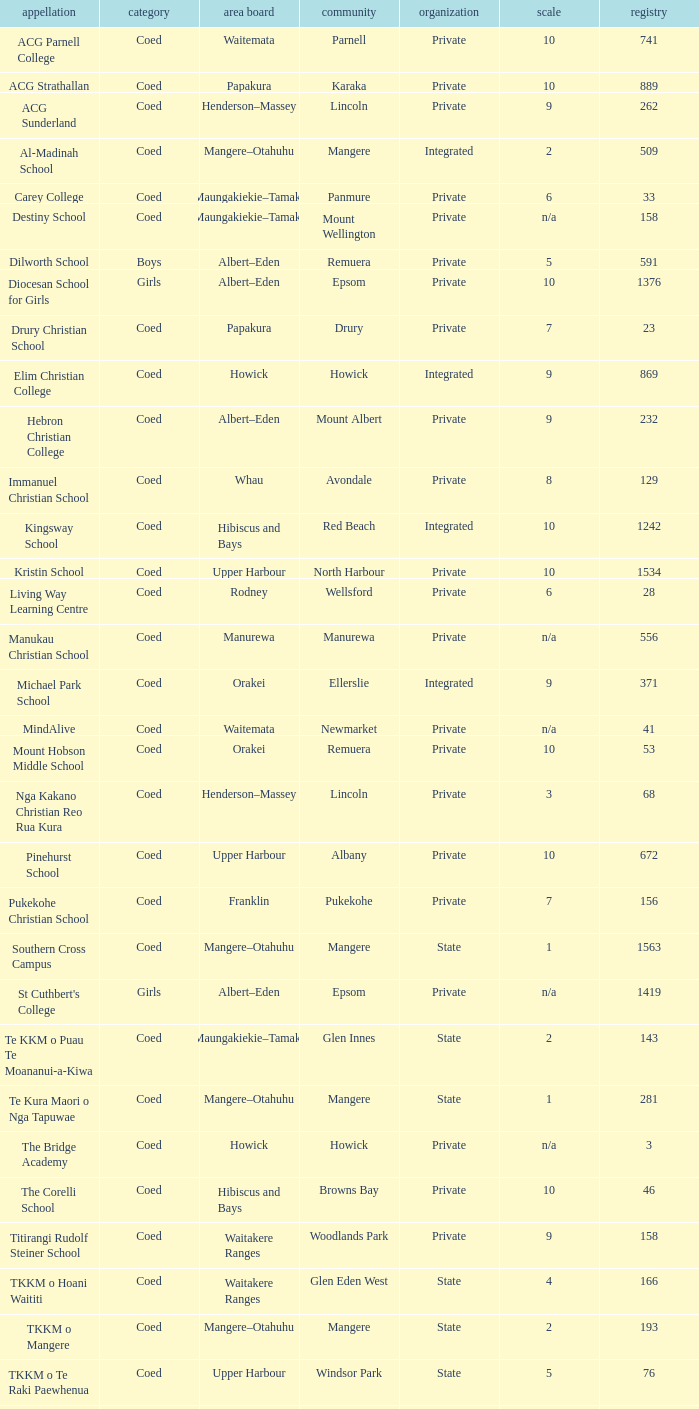What name shows as private authority and hibiscus and bays local board ? The Corelli School. 